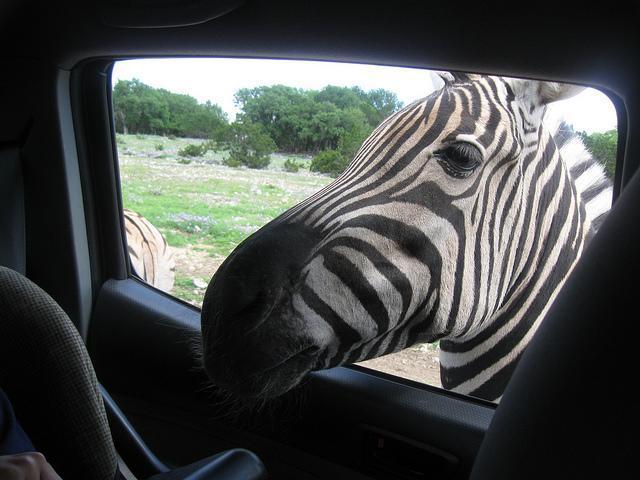How many animals are there near the vehicle that can be seen?
Give a very brief answer. 2. How many zebras are there?
Give a very brief answer. 2. 